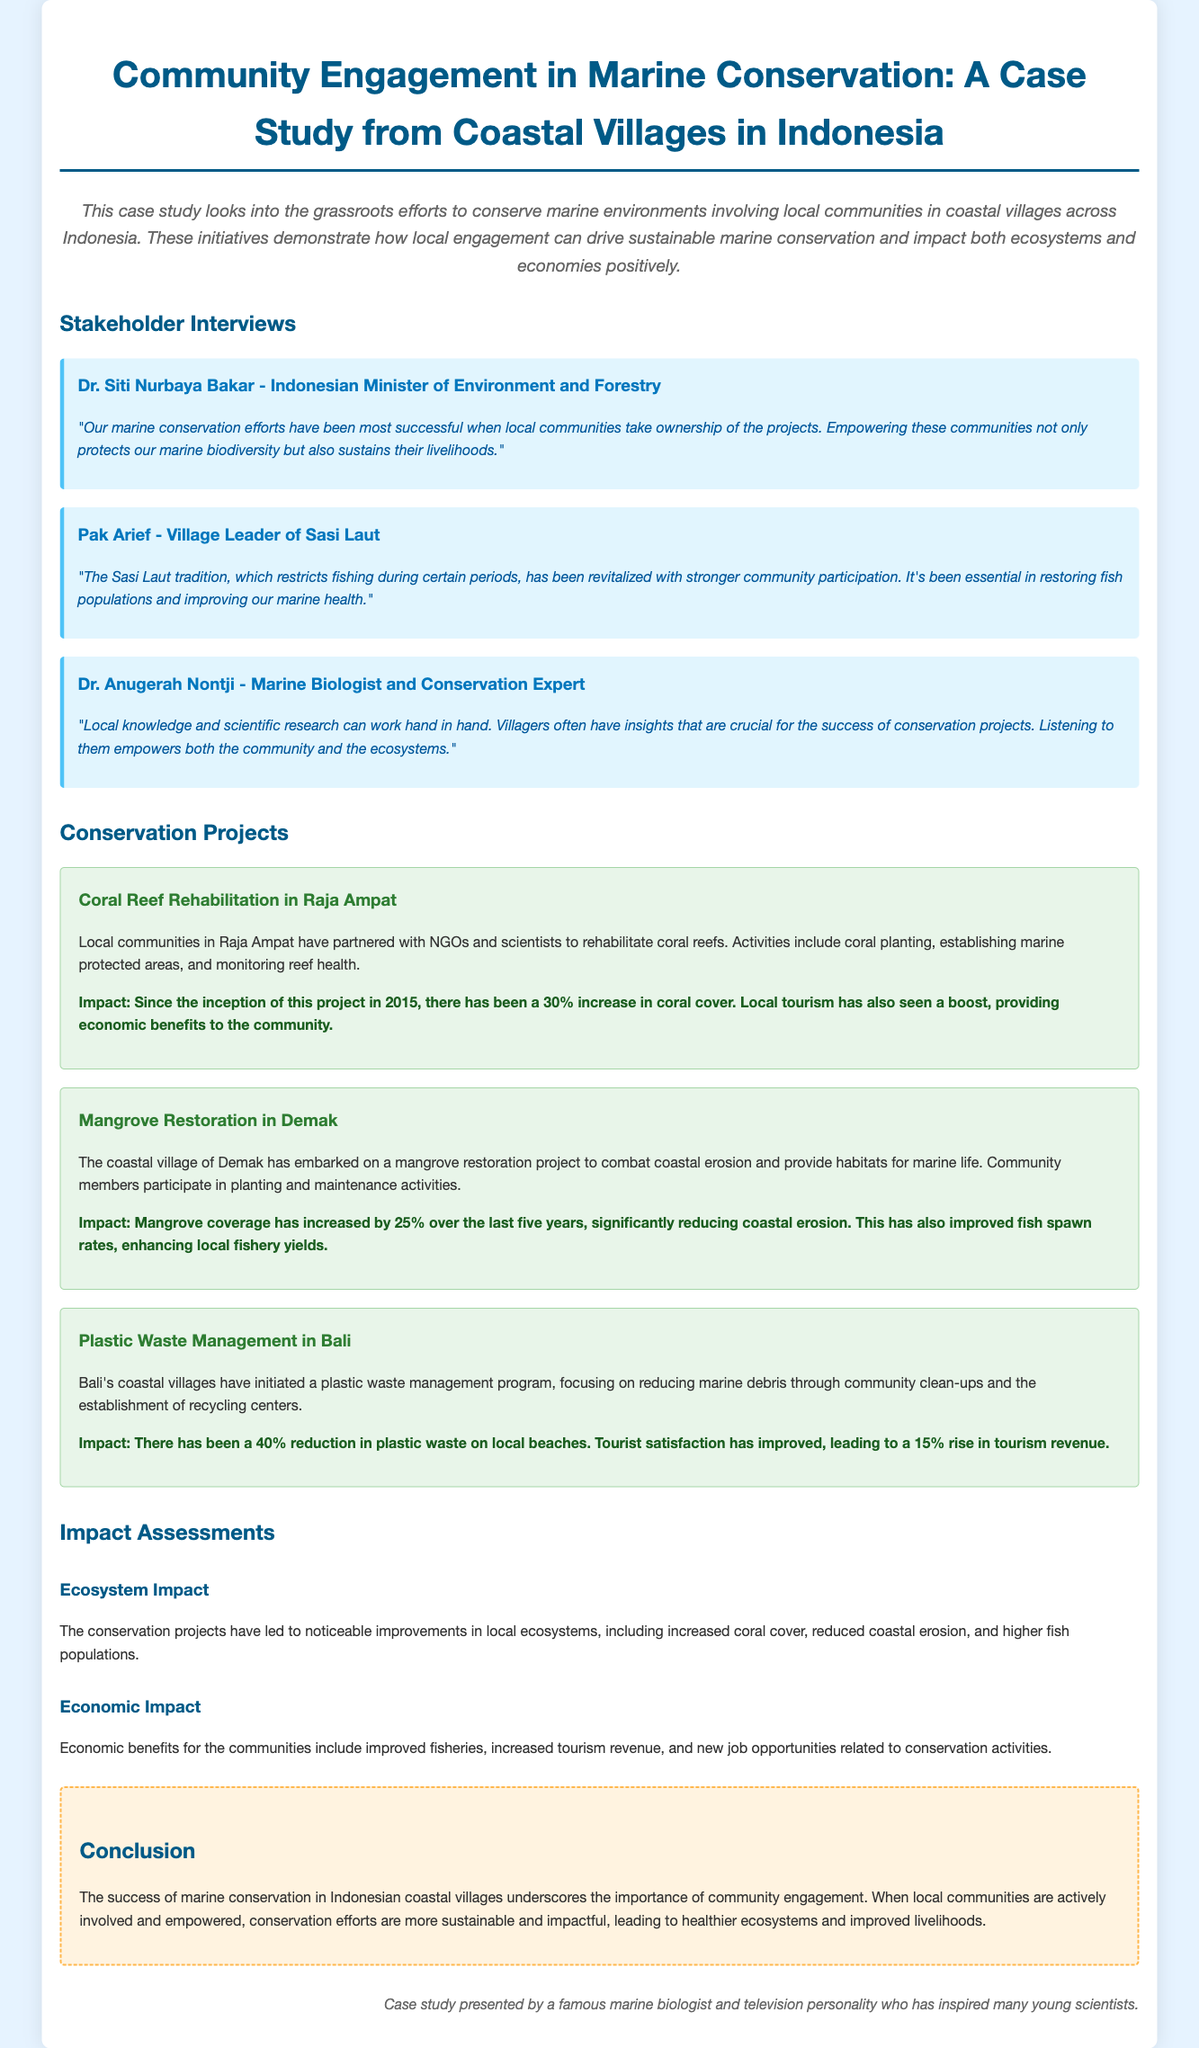What is the title of the case study? The title is explicitly stated at the beginning of the document, highlighting the focus on community engagement in marine conservation in Indonesia.
Answer: Community Engagement in Marine Conservation: A Case Study from Coastal Villages in Indonesia Who is the Indonesian Minister of Environment and Forestry? The document includes an interview with a key stakeholder representing the government perspective on marine conservation initiatives.
Answer: Dr. Siti Nurbaya Bakar What is the increase in coral cover since the Raja Ampat project began? The case study quantifies the ecological impact of the conservation project conducted in Raja Ampat.
Answer: 30% What is the main tradition revitalized in Sasi Laut? The document describes traditional practices and their importance in marine conservation efforts in the local community.
Answer: Fishing restrictions Which project had a 40% reduction in plastic waste? The projects are individually assessed, with one specifically focusing on plastic waste management in Bali.
Answer: Plastic Waste Management in Bali What year did the coral reef rehabilitation project start? The document provides a timeline for the initiation of various conservation projects, specifically noting the year for Raja Ampat.
Answer: 2015 What is the impact of the Mangrove Restoration project on fish spawn rates? The document specifically mentions the ecological benefits associated with the mangrove restoration in Demak.
Answer: Improved fish spawn rates What is highlighted as crucial for the success of conservation projects? The case study emphasizes the synergy between local knowledge and scientific research as important factors in successful conservation.
Answer: Local knowledge What is the main conclusion drawn from the case study? The conclusion summarizes the overall findings and success of the conservation initiatives, focusing on community involvement.
Answer: Community engagement leads to healthier ecosystems and improved livelihoods 